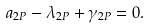Convert formula to latex. <formula><loc_0><loc_0><loc_500><loc_500>a _ { 2 P } - \lambda _ { 2 P } + \gamma _ { 2 P } = 0 .</formula> 